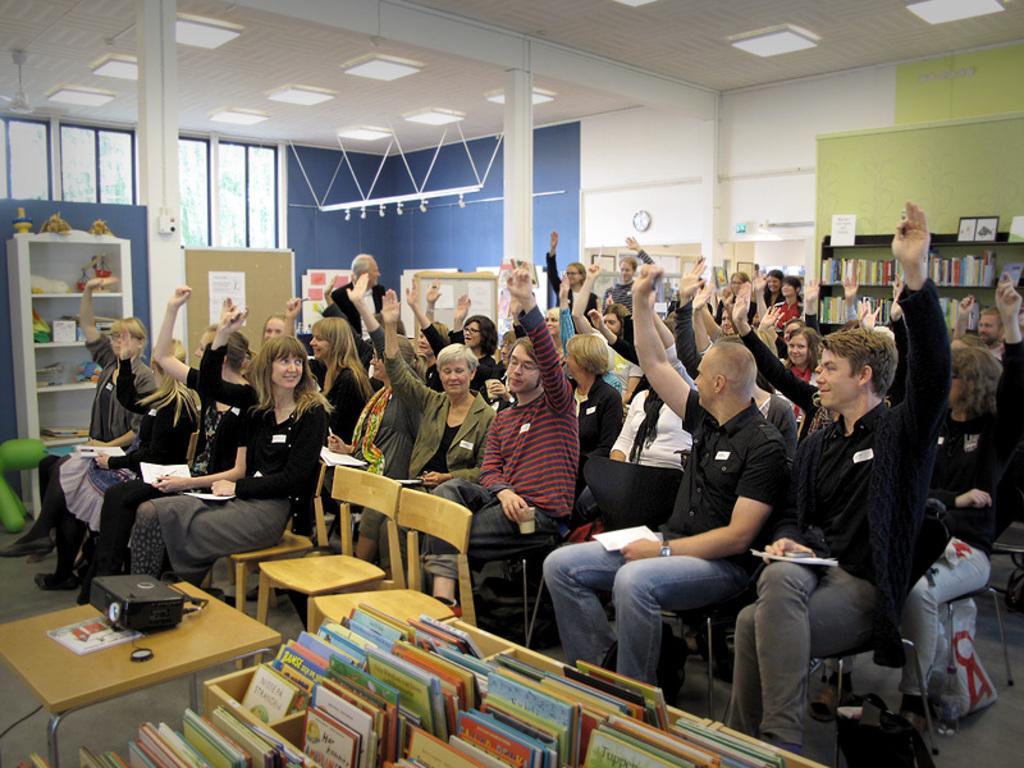Can you describe this image briefly? there are people sitting on a chair and raising their hands there are some books in front of them- 